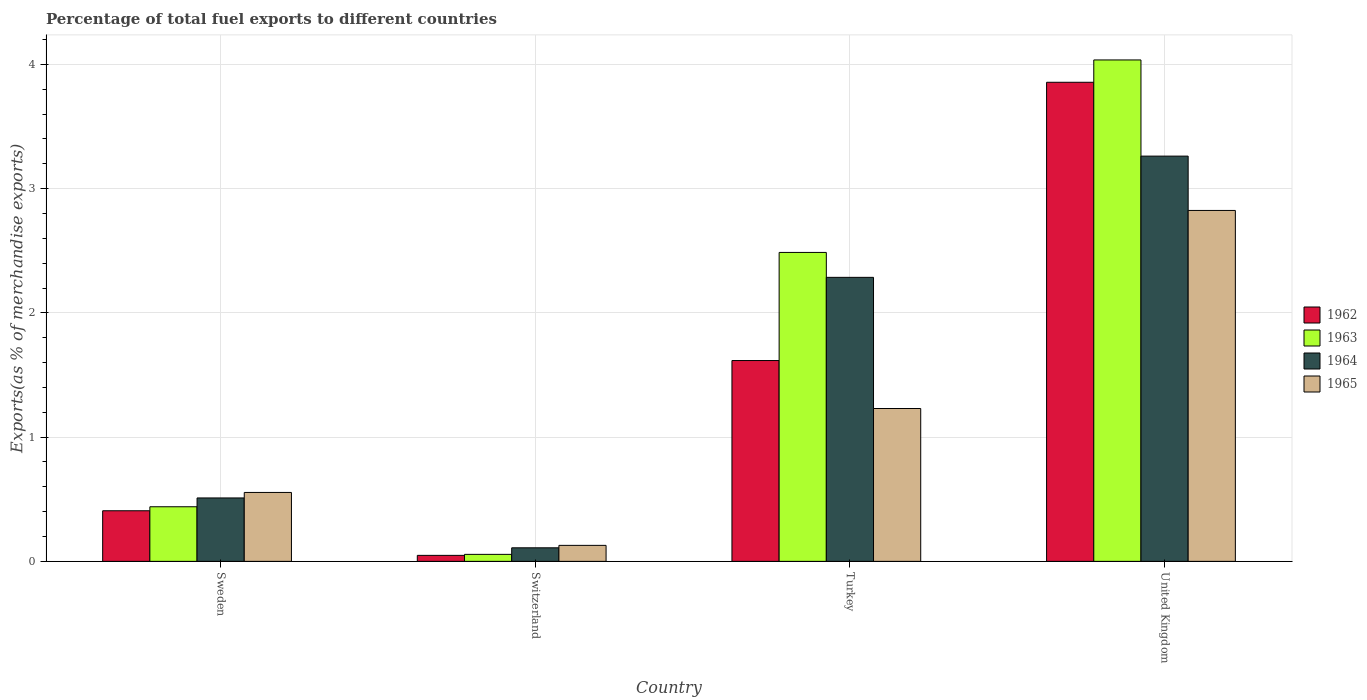How many different coloured bars are there?
Offer a terse response. 4. What is the label of the 3rd group of bars from the left?
Make the answer very short. Turkey. In how many cases, is the number of bars for a given country not equal to the number of legend labels?
Your response must be concise. 0. What is the percentage of exports to different countries in 1962 in Sweden?
Offer a very short reply. 0.41. Across all countries, what is the maximum percentage of exports to different countries in 1962?
Offer a very short reply. 3.86. Across all countries, what is the minimum percentage of exports to different countries in 1963?
Ensure brevity in your answer.  0.06. In which country was the percentage of exports to different countries in 1962 maximum?
Your answer should be very brief. United Kingdom. In which country was the percentage of exports to different countries in 1963 minimum?
Provide a succinct answer. Switzerland. What is the total percentage of exports to different countries in 1965 in the graph?
Your answer should be very brief. 4.74. What is the difference between the percentage of exports to different countries in 1963 in Sweden and that in Turkey?
Provide a succinct answer. -2.05. What is the difference between the percentage of exports to different countries in 1962 in United Kingdom and the percentage of exports to different countries in 1964 in Turkey?
Ensure brevity in your answer.  1.57. What is the average percentage of exports to different countries in 1965 per country?
Provide a succinct answer. 1.18. What is the difference between the percentage of exports to different countries of/in 1965 and percentage of exports to different countries of/in 1962 in Sweden?
Provide a succinct answer. 0.15. In how many countries, is the percentage of exports to different countries in 1964 greater than 0.6000000000000001 %?
Ensure brevity in your answer.  2. What is the ratio of the percentage of exports to different countries in 1963 in Sweden to that in Switzerland?
Provide a succinct answer. 7.81. What is the difference between the highest and the second highest percentage of exports to different countries in 1962?
Provide a short and direct response. -1.21. What is the difference between the highest and the lowest percentage of exports to different countries in 1965?
Provide a succinct answer. 2.7. What does the 2nd bar from the left in Switzerland represents?
Ensure brevity in your answer.  1963. How many bars are there?
Ensure brevity in your answer.  16. What is the difference between two consecutive major ticks on the Y-axis?
Give a very brief answer. 1. How are the legend labels stacked?
Make the answer very short. Vertical. What is the title of the graph?
Keep it short and to the point. Percentage of total fuel exports to different countries. What is the label or title of the Y-axis?
Offer a terse response. Exports(as % of merchandise exports). What is the Exports(as % of merchandise exports) of 1962 in Sweden?
Ensure brevity in your answer.  0.41. What is the Exports(as % of merchandise exports) in 1963 in Sweden?
Your answer should be compact. 0.44. What is the Exports(as % of merchandise exports) of 1964 in Sweden?
Make the answer very short. 0.51. What is the Exports(as % of merchandise exports) in 1965 in Sweden?
Keep it short and to the point. 0.55. What is the Exports(as % of merchandise exports) of 1962 in Switzerland?
Keep it short and to the point. 0.05. What is the Exports(as % of merchandise exports) in 1963 in Switzerland?
Your answer should be very brief. 0.06. What is the Exports(as % of merchandise exports) in 1964 in Switzerland?
Give a very brief answer. 0.11. What is the Exports(as % of merchandise exports) in 1965 in Switzerland?
Offer a very short reply. 0.13. What is the Exports(as % of merchandise exports) of 1962 in Turkey?
Your answer should be very brief. 1.62. What is the Exports(as % of merchandise exports) of 1963 in Turkey?
Offer a very short reply. 2.49. What is the Exports(as % of merchandise exports) of 1964 in Turkey?
Keep it short and to the point. 2.29. What is the Exports(as % of merchandise exports) of 1965 in Turkey?
Provide a succinct answer. 1.23. What is the Exports(as % of merchandise exports) in 1962 in United Kingdom?
Provide a succinct answer. 3.86. What is the Exports(as % of merchandise exports) in 1963 in United Kingdom?
Keep it short and to the point. 4.04. What is the Exports(as % of merchandise exports) of 1964 in United Kingdom?
Ensure brevity in your answer.  3.26. What is the Exports(as % of merchandise exports) of 1965 in United Kingdom?
Your answer should be very brief. 2.82. Across all countries, what is the maximum Exports(as % of merchandise exports) of 1962?
Give a very brief answer. 3.86. Across all countries, what is the maximum Exports(as % of merchandise exports) of 1963?
Give a very brief answer. 4.04. Across all countries, what is the maximum Exports(as % of merchandise exports) in 1964?
Your answer should be compact. 3.26. Across all countries, what is the maximum Exports(as % of merchandise exports) in 1965?
Give a very brief answer. 2.82. Across all countries, what is the minimum Exports(as % of merchandise exports) of 1962?
Make the answer very short. 0.05. Across all countries, what is the minimum Exports(as % of merchandise exports) of 1963?
Your answer should be very brief. 0.06. Across all countries, what is the minimum Exports(as % of merchandise exports) of 1964?
Your answer should be very brief. 0.11. Across all countries, what is the minimum Exports(as % of merchandise exports) of 1965?
Offer a very short reply. 0.13. What is the total Exports(as % of merchandise exports) in 1962 in the graph?
Offer a terse response. 5.93. What is the total Exports(as % of merchandise exports) of 1963 in the graph?
Offer a very short reply. 7.02. What is the total Exports(as % of merchandise exports) of 1964 in the graph?
Your answer should be very brief. 6.17. What is the total Exports(as % of merchandise exports) of 1965 in the graph?
Your answer should be very brief. 4.74. What is the difference between the Exports(as % of merchandise exports) in 1962 in Sweden and that in Switzerland?
Make the answer very short. 0.36. What is the difference between the Exports(as % of merchandise exports) in 1963 in Sweden and that in Switzerland?
Give a very brief answer. 0.38. What is the difference between the Exports(as % of merchandise exports) in 1964 in Sweden and that in Switzerland?
Your response must be concise. 0.4. What is the difference between the Exports(as % of merchandise exports) of 1965 in Sweden and that in Switzerland?
Provide a short and direct response. 0.43. What is the difference between the Exports(as % of merchandise exports) of 1962 in Sweden and that in Turkey?
Provide a short and direct response. -1.21. What is the difference between the Exports(as % of merchandise exports) of 1963 in Sweden and that in Turkey?
Make the answer very short. -2.05. What is the difference between the Exports(as % of merchandise exports) of 1964 in Sweden and that in Turkey?
Give a very brief answer. -1.78. What is the difference between the Exports(as % of merchandise exports) of 1965 in Sweden and that in Turkey?
Offer a very short reply. -0.68. What is the difference between the Exports(as % of merchandise exports) in 1962 in Sweden and that in United Kingdom?
Ensure brevity in your answer.  -3.45. What is the difference between the Exports(as % of merchandise exports) of 1963 in Sweden and that in United Kingdom?
Give a very brief answer. -3.6. What is the difference between the Exports(as % of merchandise exports) of 1964 in Sweden and that in United Kingdom?
Ensure brevity in your answer.  -2.75. What is the difference between the Exports(as % of merchandise exports) in 1965 in Sweden and that in United Kingdom?
Your answer should be compact. -2.27. What is the difference between the Exports(as % of merchandise exports) in 1962 in Switzerland and that in Turkey?
Ensure brevity in your answer.  -1.57. What is the difference between the Exports(as % of merchandise exports) in 1963 in Switzerland and that in Turkey?
Provide a short and direct response. -2.43. What is the difference between the Exports(as % of merchandise exports) of 1964 in Switzerland and that in Turkey?
Make the answer very short. -2.18. What is the difference between the Exports(as % of merchandise exports) in 1965 in Switzerland and that in Turkey?
Your answer should be compact. -1.1. What is the difference between the Exports(as % of merchandise exports) in 1962 in Switzerland and that in United Kingdom?
Offer a very short reply. -3.81. What is the difference between the Exports(as % of merchandise exports) in 1963 in Switzerland and that in United Kingdom?
Keep it short and to the point. -3.98. What is the difference between the Exports(as % of merchandise exports) in 1964 in Switzerland and that in United Kingdom?
Offer a terse response. -3.15. What is the difference between the Exports(as % of merchandise exports) in 1965 in Switzerland and that in United Kingdom?
Ensure brevity in your answer.  -2.7. What is the difference between the Exports(as % of merchandise exports) in 1962 in Turkey and that in United Kingdom?
Your answer should be compact. -2.24. What is the difference between the Exports(as % of merchandise exports) in 1963 in Turkey and that in United Kingdom?
Offer a terse response. -1.55. What is the difference between the Exports(as % of merchandise exports) of 1964 in Turkey and that in United Kingdom?
Provide a succinct answer. -0.98. What is the difference between the Exports(as % of merchandise exports) of 1965 in Turkey and that in United Kingdom?
Ensure brevity in your answer.  -1.59. What is the difference between the Exports(as % of merchandise exports) of 1962 in Sweden and the Exports(as % of merchandise exports) of 1963 in Switzerland?
Give a very brief answer. 0.35. What is the difference between the Exports(as % of merchandise exports) in 1962 in Sweden and the Exports(as % of merchandise exports) in 1964 in Switzerland?
Provide a short and direct response. 0.3. What is the difference between the Exports(as % of merchandise exports) in 1962 in Sweden and the Exports(as % of merchandise exports) in 1965 in Switzerland?
Make the answer very short. 0.28. What is the difference between the Exports(as % of merchandise exports) in 1963 in Sweden and the Exports(as % of merchandise exports) in 1964 in Switzerland?
Your answer should be very brief. 0.33. What is the difference between the Exports(as % of merchandise exports) of 1963 in Sweden and the Exports(as % of merchandise exports) of 1965 in Switzerland?
Give a very brief answer. 0.31. What is the difference between the Exports(as % of merchandise exports) in 1964 in Sweden and the Exports(as % of merchandise exports) in 1965 in Switzerland?
Ensure brevity in your answer.  0.38. What is the difference between the Exports(as % of merchandise exports) in 1962 in Sweden and the Exports(as % of merchandise exports) in 1963 in Turkey?
Your answer should be very brief. -2.08. What is the difference between the Exports(as % of merchandise exports) in 1962 in Sweden and the Exports(as % of merchandise exports) in 1964 in Turkey?
Offer a very short reply. -1.88. What is the difference between the Exports(as % of merchandise exports) of 1962 in Sweden and the Exports(as % of merchandise exports) of 1965 in Turkey?
Your answer should be very brief. -0.82. What is the difference between the Exports(as % of merchandise exports) of 1963 in Sweden and the Exports(as % of merchandise exports) of 1964 in Turkey?
Offer a very short reply. -1.85. What is the difference between the Exports(as % of merchandise exports) in 1963 in Sweden and the Exports(as % of merchandise exports) in 1965 in Turkey?
Your answer should be very brief. -0.79. What is the difference between the Exports(as % of merchandise exports) in 1964 in Sweden and the Exports(as % of merchandise exports) in 1965 in Turkey?
Keep it short and to the point. -0.72. What is the difference between the Exports(as % of merchandise exports) of 1962 in Sweden and the Exports(as % of merchandise exports) of 1963 in United Kingdom?
Your response must be concise. -3.63. What is the difference between the Exports(as % of merchandise exports) in 1962 in Sweden and the Exports(as % of merchandise exports) in 1964 in United Kingdom?
Ensure brevity in your answer.  -2.85. What is the difference between the Exports(as % of merchandise exports) of 1962 in Sweden and the Exports(as % of merchandise exports) of 1965 in United Kingdom?
Make the answer very short. -2.42. What is the difference between the Exports(as % of merchandise exports) of 1963 in Sweden and the Exports(as % of merchandise exports) of 1964 in United Kingdom?
Make the answer very short. -2.82. What is the difference between the Exports(as % of merchandise exports) in 1963 in Sweden and the Exports(as % of merchandise exports) in 1965 in United Kingdom?
Your answer should be compact. -2.38. What is the difference between the Exports(as % of merchandise exports) of 1964 in Sweden and the Exports(as % of merchandise exports) of 1965 in United Kingdom?
Offer a very short reply. -2.31. What is the difference between the Exports(as % of merchandise exports) in 1962 in Switzerland and the Exports(as % of merchandise exports) in 1963 in Turkey?
Your answer should be compact. -2.44. What is the difference between the Exports(as % of merchandise exports) in 1962 in Switzerland and the Exports(as % of merchandise exports) in 1964 in Turkey?
Give a very brief answer. -2.24. What is the difference between the Exports(as % of merchandise exports) in 1962 in Switzerland and the Exports(as % of merchandise exports) in 1965 in Turkey?
Your answer should be compact. -1.18. What is the difference between the Exports(as % of merchandise exports) of 1963 in Switzerland and the Exports(as % of merchandise exports) of 1964 in Turkey?
Offer a very short reply. -2.23. What is the difference between the Exports(as % of merchandise exports) of 1963 in Switzerland and the Exports(as % of merchandise exports) of 1965 in Turkey?
Make the answer very short. -1.17. What is the difference between the Exports(as % of merchandise exports) in 1964 in Switzerland and the Exports(as % of merchandise exports) in 1965 in Turkey?
Give a very brief answer. -1.12. What is the difference between the Exports(as % of merchandise exports) in 1962 in Switzerland and the Exports(as % of merchandise exports) in 1963 in United Kingdom?
Offer a very short reply. -3.99. What is the difference between the Exports(as % of merchandise exports) of 1962 in Switzerland and the Exports(as % of merchandise exports) of 1964 in United Kingdom?
Make the answer very short. -3.21. What is the difference between the Exports(as % of merchandise exports) in 1962 in Switzerland and the Exports(as % of merchandise exports) in 1965 in United Kingdom?
Make the answer very short. -2.78. What is the difference between the Exports(as % of merchandise exports) in 1963 in Switzerland and the Exports(as % of merchandise exports) in 1964 in United Kingdom?
Offer a very short reply. -3.21. What is the difference between the Exports(as % of merchandise exports) in 1963 in Switzerland and the Exports(as % of merchandise exports) in 1965 in United Kingdom?
Keep it short and to the point. -2.77. What is the difference between the Exports(as % of merchandise exports) in 1964 in Switzerland and the Exports(as % of merchandise exports) in 1965 in United Kingdom?
Keep it short and to the point. -2.72. What is the difference between the Exports(as % of merchandise exports) in 1962 in Turkey and the Exports(as % of merchandise exports) in 1963 in United Kingdom?
Offer a very short reply. -2.42. What is the difference between the Exports(as % of merchandise exports) in 1962 in Turkey and the Exports(as % of merchandise exports) in 1964 in United Kingdom?
Your response must be concise. -1.65. What is the difference between the Exports(as % of merchandise exports) in 1962 in Turkey and the Exports(as % of merchandise exports) in 1965 in United Kingdom?
Make the answer very short. -1.21. What is the difference between the Exports(as % of merchandise exports) in 1963 in Turkey and the Exports(as % of merchandise exports) in 1964 in United Kingdom?
Your response must be concise. -0.78. What is the difference between the Exports(as % of merchandise exports) in 1963 in Turkey and the Exports(as % of merchandise exports) in 1965 in United Kingdom?
Give a very brief answer. -0.34. What is the difference between the Exports(as % of merchandise exports) of 1964 in Turkey and the Exports(as % of merchandise exports) of 1965 in United Kingdom?
Give a very brief answer. -0.54. What is the average Exports(as % of merchandise exports) of 1962 per country?
Provide a short and direct response. 1.48. What is the average Exports(as % of merchandise exports) of 1963 per country?
Your answer should be very brief. 1.75. What is the average Exports(as % of merchandise exports) of 1964 per country?
Your answer should be very brief. 1.54. What is the average Exports(as % of merchandise exports) in 1965 per country?
Give a very brief answer. 1.18. What is the difference between the Exports(as % of merchandise exports) of 1962 and Exports(as % of merchandise exports) of 1963 in Sweden?
Offer a very short reply. -0.03. What is the difference between the Exports(as % of merchandise exports) in 1962 and Exports(as % of merchandise exports) in 1964 in Sweden?
Your answer should be compact. -0.1. What is the difference between the Exports(as % of merchandise exports) of 1962 and Exports(as % of merchandise exports) of 1965 in Sweden?
Your answer should be very brief. -0.15. What is the difference between the Exports(as % of merchandise exports) of 1963 and Exports(as % of merchandise exports) of 1964 in Sweden?
Keep it short and to the point. -0.07. What is the difference between the Exports(as % of merchandise exports) of 1963 and Exports(as % of merchandise exports) of 1965 in Sweden?
Offer a very short reply. -0.12. What is the difference between the Exports(as % of merchandise exports) in 1964 and Exports(as % of merchandise exports) in 1965 in Sweden?
Your response must be concise. -0.04. What is the difference between the Exports(as % of merchandise exports) in 1962 and Exports(as % of merchandise exports) in 1963 in Switzerland?
Provide a short and direct response. -0.01. What is the difference between the Exports(as % of merchandise exports) in 1962 and Exports(as % of merchandise exports) in 1964 in Switzerland?
Your answer should be compact. -0.06. What is the difference between the Exports(as % of merchandise exports) of 1962 and Exports(as % of merchandise exports) of 1965 in Switzerland?
Your answer should be very brief. -0.08. What is the difference between the Exports(as % of merchandise exports) of 1963 and Exports(as % of merchandise exports) of 1964 in Switzerland?
Provide a short and direct response. -0.05. What is the difference between the Exports(as % of merchandise exports) in 1963 and Exports(as % of merchandise exports) in 1965 in Switzerland?
Your answer should be compact. -0.07. What is the difference between the Exports(as % of merchandise exports) of 1964 and Exports(as % of merchandise exports) of 1965 in Switzerland?
Your response must be concise. -0.02. What is the difference between the Exports(as % of merchandise exports) of 1962 and Exports(as % of merchandise exports) of 1963 in Turkey?
Provide a succinct answer. -0.87. What is the difference between the Exports(as % of merchandise exports) in 1962 and Exports(as % of merchandise exports) in 1964 in Turkey?
Offer a very short reply. -0.67. What is the difference between the Exports(as % of merchandise exports) of 1962 and Exports(as % of merchandise exports) of 1965 in Turkey?
Keep it short and to the point. 0.39. What is the difference between the Exports(as % of merchandise exports) in 1963 and Exports(as % of merchandise exports) in 1964 in Turkey?
Provide a short and direct response. 0.2. What is the difference between the Exports(as % of merchandise exports) of 1963 and Exports(as % of merchandise exports) of 1965 in Turkey?
Ensure brevity in your answer.  1.26. What is the difference between the Exports(as % of merchandise exports) in 1964 and Exports(as % of merchandise exports) in 1965 in Turkey?
Keep it short and to the point. 1.06. What is the difference between the Exports(as % of merchandise exports) in 1962 and Exports(as % of merchandise exports) in 1963 in United Kingdom?
Offer a terse response. -0.18. What is the difference between the Exports(as % of merchandise exports) of 1962 and Exports(as % of merchandise exports) of 1964 in United Kingdom?
Ensure brevity in your answer.  0.59. What is the difference between the Exports(as % of merchandise exports) of 1962 and Exports(as % of merchandise exports) of 1965 in United Kingdom?
Your response must be concise. 1.03. What is the difference between the Exports(as % of merchandise exports) of 1963 and Exports(as % of merchandise exports) of 1964 in United Kingdom?
Offer a very short reply. 0.77. What is the difference between the Exports(as % of merchandise exports) in 1963 and Exports(as % of merchandise exports) in 1965 in United Kingdom?
Give a very brief answer. 1.21. What is the difference between the Exports(as % of merchandise exports) in 1964 and Exports(as % of merchandise exports) in 1965 in United Kingdom?
Offer a very short reply. 0.44. What is the ratio of the Exports(as % of merchandise exports) of 1962 in Sweden to that in Switzerland?
Provide a succinct answer. 8.44. What is the ratio of the Exports(as % of merchandise exports) in 1963 in Sweden to that in Switzerland?
Offer a very short reply. 7.81. What is the ratio of the Exports(as % of merchandise exports) of 1964 in Sweden to that in Switzerland?
Provide a succinct answer. 4.68. What is the ratio of the Exports(as % of merchandise exports) of 1965 in Sweden to that in Switzerland?
Your answer should be very brief. 4.31. What is the ratio of the Exports(as % of merchandise exports) in 1962 in Sweden to that in Turkey?
Ensure brevity in your answer.  0.25. What is the ratio of the Exports(as % of merchandise exports) in 1963 in Sweden to that in Turkey?
Keep it short and to the point. 0.18. What is the ratio of the Exports(as % of merchandise exports) of 1964 in Sweden to that in Turkey?
Your response must be concise. 0.22. What is the ratio of the Exports(as % of merchandise exports) in 1965 in Sweden to that in Turkey?
Give a very brief answer. 0.45. What is the ratio of the Exports(as % of merchandise exports) in 1962 in Sweden to that in United Kingdom?
Keep it short and to the point. 0.11. What is the ratio of the Exports(as % of merchandise exports) of 1963 in Sweden to that in United Kingdom?
Ensure brevity in your answer.  0.11. What is the ratio of the Exports(as % of merchandise exports) in 1964 in Sweden to that in United Kingdom?
Offer a very short reply. 0.16. What is the ratio of the Exports(as % of merchandise exports) in 1965 in Sweden to that in United Kingdom?
Give a very brief answer. 0.2. What is the ratio of the Exports(as % of merchandise exports) of 1962 in Switzerland to that in Turkey?
Offer a very short reply. 0.03. What is the ratio of the Exports(as % of merchandise exports) in 1963 in Switzerland to that in Turkey?
Keep it short and to the point. 0.02. What is the ratio of the Exports(as % of merchandise exports) of 1964 in Switzerland to that in Turkey?
Provide a short and direct response. 0.05. What is the ratio of the Exports(as % of merchandise exports) of 1965 in Switzerland to that in Turkey?
Ensure brevity in your answer.  0.1. What is the ratio of the Exports(as % of merchandise exports) of 1962 in Switzerland to that in United Kingdom?
Ensure brevity in your answer.  0.01. What is the ratio of the Exports(as % of merchandise exports) of 1963 in Switzerland to that in United Kingdom?
Provide a short and direct response. 0.01. What is the ratio of the Exports(as % of merchandise exports) of 1964 in Switzerland to that in United Kingdom?
Offer a very short reply. 0.03. What is the ratio of the Exports(as % of merchandise exports) of 1965 in Switzerland to that in United Kingdom?
Make the answer very short. 0.05. What is the ratio of the Exports(as % of merchandise exports) of 1962 in Turkey to that in United Kingdom?
Offer a terse response. 0.42. What is the ratio of the Exports(as % of merchandise exports) in 1963 in Turkey to that in United Kingdom?
Ensure brevity in your answer.  0.62. What is the ratio of the Exports(as % of merchandise exports) of 1964 in Turkey to that in United Kingdom?
Offer a terse response. 0.7. What is the ratio of the Exports(as % of merchandise exports) of 1965 in Turkey to that in United Kingdom?
Offer a very short reply. 0.44. What is the difference between the highest and the second highest Exports(as % of merchandise exports) of 1962?
Your answer should be compact. 2.24. What is the difference between the highest and the second highest Exports(as % of merchandise exports) of 1963?
Offer a very short reply. 1.55. What is the difference between the highest and the second highest Exports(as % of merchandise exports) in 1964?
Your answer should be compact. 0.98. What is the difference between the highest and the second highest Exports(as % of merchandise exports) of 1965?
Your answer should be very brief. 1.59. What is the difference between the highest and the lowest Exports(as % of merchandise exports) of 1962?
Keep it short and to the point. 3.81. What is the difference between the highest and the lowest Exports(as % of merchandise exports) in 1963?
Your response must be concise. 3.98. What is the difference between the highest and the lowest Exports(as % of merchandise exports) in 1964?
Your answer should be compact. 3.15. What is the difference between the highest and the lowest Exports(as % of merchandise exports) of 1965?
Ensure brevity in your answer.  2.7. 